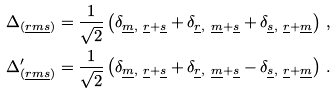Convert formula to latex. <formula><loc_0><loc_0><loc_500><loc_500>\Delta _ { ( \underline { r m s } ) } & = \frac { 1 } { \sqrt { 2 } } \left ( \delta _ { \underline { m } , \ \underline { r } + \underline { s } } + \delta _ { \underline { r } , \ \underline { m } + \underline { s } } + \delta _ { \underline { s } , \ \underline { r } + \underline { m } } \right ) \, , \\ \Delta ^ { \prime } _ { ( \underline { r m s } ) } & = \frac { 1 } { \sqrt { 2 } } \left ( \delta _ { \underline { m } , \ \underline { r } + \underline { s } } + \delta _ { \underline { r } , \ \underline { m } + \underline { s } } - \delta _ { \underline { s } , \ \underline { r } + \underline { m } } \right ) \, .</formula> 